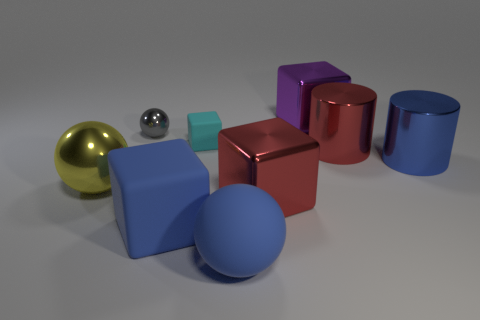Subtract all green cubes. Subtract all cyan spheres. How many cubes are left? 4 Subtract all cylinders. How many objects are left? 7 Subtract all yellow metallic spheres. Subtract all spheres. How many objects are left? 5 Add 1 big red cylinders. How many big red cylinders are left? 2 Add 8 gray matte cubes. How many gray matte cubes exist? 8 Subtract 0 cyan cylinders. How many objects are left? 9 